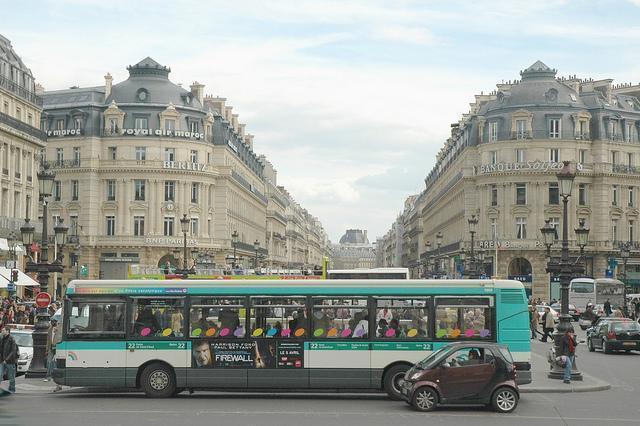How many sinks are to the right of the shower?
Give a very brief answer. 0. 